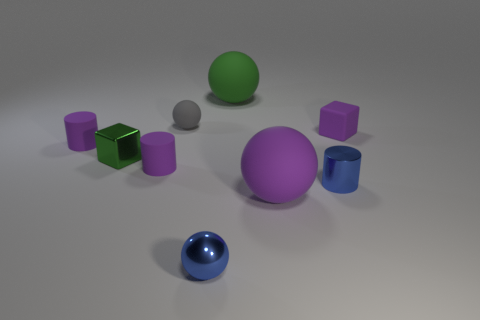There is a matte thing that is behind the tiny gray object; what is its size?
Make the answer very short. Large. What number of large objects are yellow blocks or gray spheres?
Make the answer very short. 0. The tiny cylinder that is behind the small metallic cylinder and on the right side of the green metallic object is what color?
Your response must be concise. Purple. Is there another large green object that has the same shape as the big green rubber thing?
Provide a short and direct response. No. What material is the tiny purple cube?
Provide a short and direct response. Rubber. Are there any tiny cylinders on the left side of the gray object?
Offer a terse response. Yes. Is the green matte thing the same shape as the tiny green metallic thing?
Give a very brief answer. No. How many other things are the same size as the green metallic thing?
Provide a succinct answer. 6. What number of objects are blocks that are on the left side of the rubber block or tiny rubber cylinders?
Your answer should be compact. 3. The tiny rubber block is what color?
Offer a terse response. Purple. 